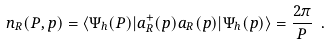Convert formula to latex. <formula><loc_0><loc_0><loc_500><loc_500>n _ { R } ( P , p ) = \langle \Psi _ { h } ( P ) | a _ { R } ^ { + } ( p ) a _ { R } ( p ) | \Psi _ { h } ( p ) \rangle = \frac { 2 \pi } P \ .</formula> 